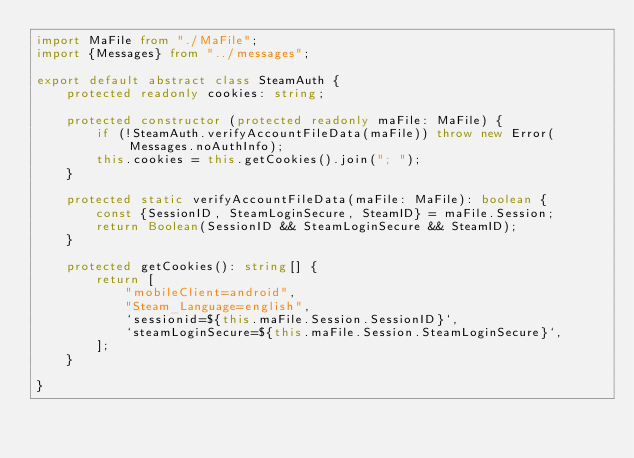Convert code to text. <code><loc_0><loc_0><loc_500><loc_500><_TypeScript_>import MaFile from "./MaFile";
import {Messages} from "../messages";

export default abstract class SteamAuth {
    protected readonly cookies: string;

    protected constructor (protected readonly maFile: MaFile) {
        if (!SteamAuth.verifyAccountFileData(maFile)) throw new Error(Messages.noAuthInfo);
        this.cookies = this.getCookies().join("; ");
    }

    protected static verifyAccountFileData(maFile: MaFile): boolean {
        const {SessionID, SteamLoginSecure, SteamID} = maFile.Session;
        return Boolean(SessionID && SteamLoginSecure && SteamID);
    }

    protected getCookies(): string[] {
        return [
            "mobileClient=android",
            "Steam_Language=english",
            `sessionid=${this.maFile.Session.SessionID}`,
            `steamLoginSecure=${this.maFile.Session.SteamLoginSecure}`,
        ];
    }

}</code> 